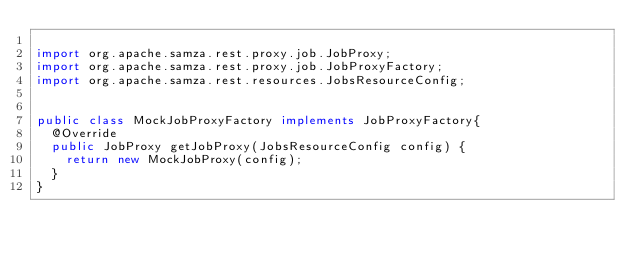Convert code to text. <code><loc_0><loc_0><loc_500><loc_500><_Java_>
import org.apache.samza.rest.proxy.job.JobProxy;
import org.apache.samza.rest.proxy.job.JobProxyFactory;
import org.apache.samza.rest.resources.JobsResourceConfig;


public class MockJobProxyFactory implements JobProxyFactory{
  @Override
  public JobProxy getJobProxy(JobsResourceConfig config) {
    return new MockJobProxy(config);
  }
}
</code> 